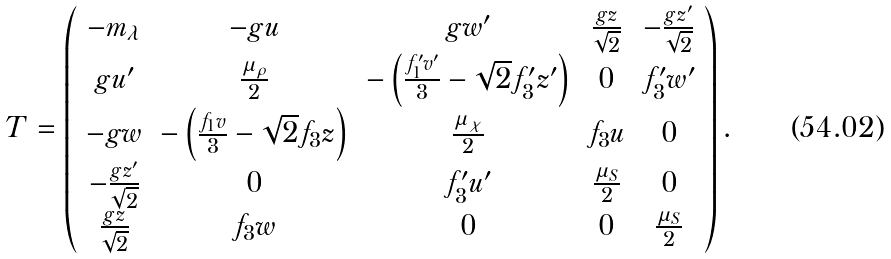<formula> <loc_0><loc_0><loc_500><loc_500>T = \left ( \begin{array} { c c c c c } - m _ { \lambda } & - g u & g w ^ { \prime } & \frac { g z } { \sqrt { 2 } } & - \frac { g z ^ { \prime } } { \sqrt { 2 } } \\ g u ^ { \prime } & \frac { \mu _ { \rho } } { 2 } & - \left ( \frac { f _ { 1 } ^ { \prime } v ^ { \prime } } { 3 } - \sqrt { 2 } f _ { 3 } ^ { \prime } z ^ { \prime } \right ) & 0 & f _ { 3 } ^ { \prime } w ^ { \prime } \\ - g w & - \left ( \frac { f _ { 1 } v } { 3 } - \sqrt { 2 } f _ { 3 } z \right ) & \frac { \mu _ { \chi } } { 2 } & f _ { 3 } u & 0 \\ - \frac { g z ^ { \prime } } { \sqrt { 2 } } & 0 & f _ { 3 } ^ { \prime } u ^ { \prime } & \frac { \mu _ { S } } { 2 } & 0 \\ \frac { g z } { \sqrt { 2 } } & f _ { 3 } w & 0 & 0 & \frac { \mu _ { S } } { 2 } \end{array} \right ) .</formula> 